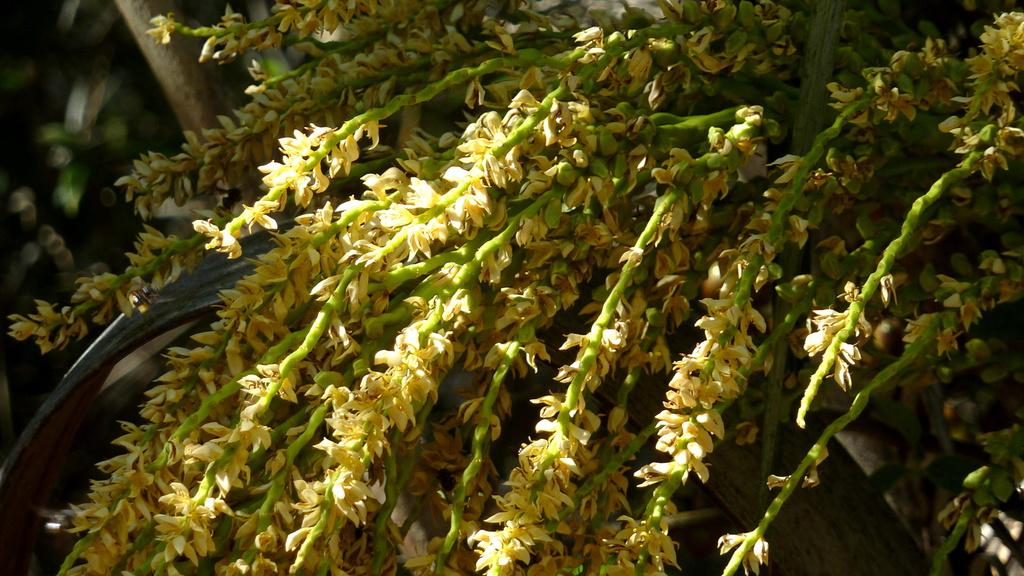What is the main subject of the image? The main subject of the image is branches with flowers. Can you describe the background of the image? The background of the image is blurred. What type of hen can be seen sitting on the flame in the image? There is no hen or flame present in the image; it features branches with flowers and a blurred background. 